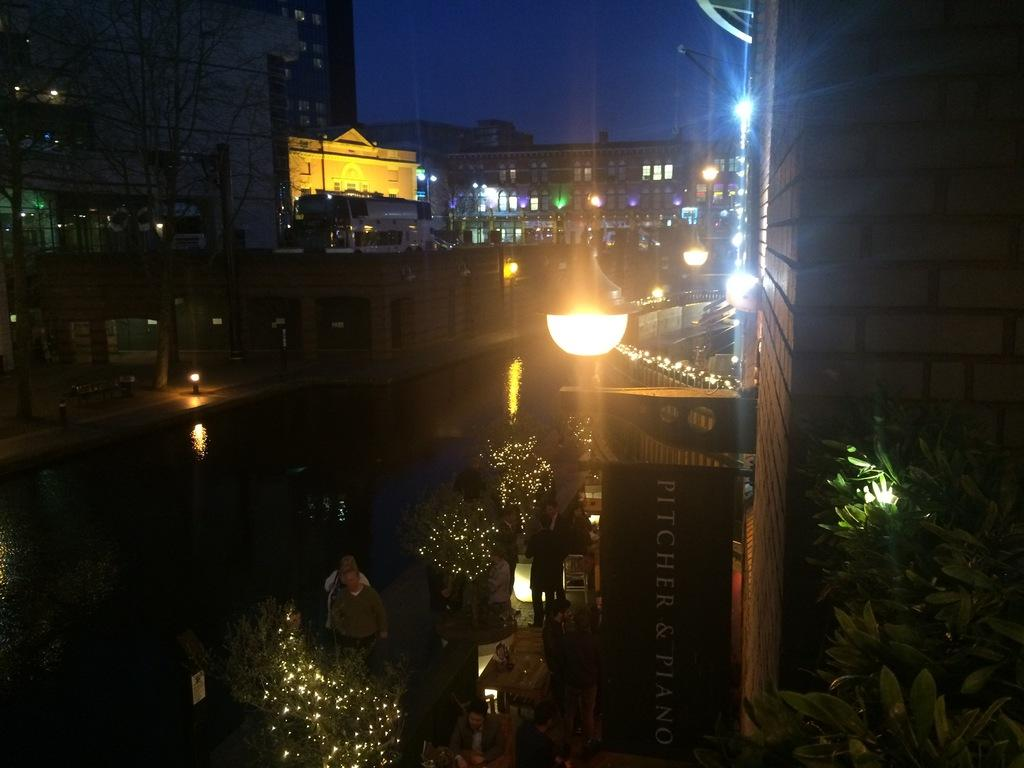What can be seen in the foreground of the image? In the foreground of the image, there are plants, people, light, and a stall. What type of plants are visible in the foreground? The specific type of plants is not mentioned, but they are present in the foreground. What is the purpose of the stall in the foreground? The purpose of the stall is not specified in the facts provided. What can be seen in the background of the image? In the background of the image, there are buildings, trees, and the sky. What type of curtain can be seen hanging from the trees in the background? There is no mention of a curtain in the image, and no curtain is visible hanging from the trees in the background. What type of toy is being played with by the people in the foreground? There is no mention of a toy in the image, and no toy is visible being played with by the people in the foreground. 